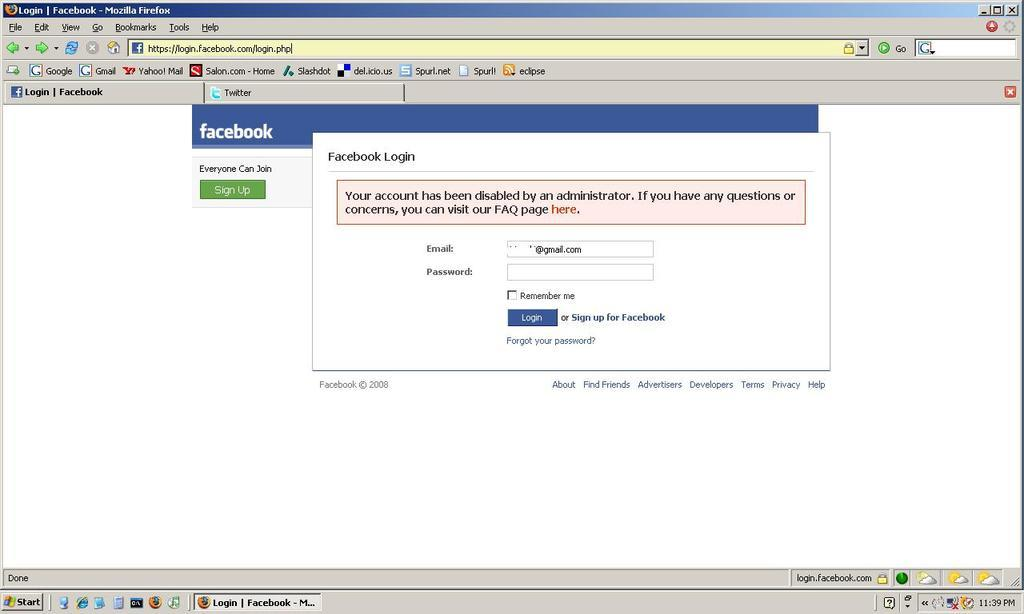<image>
Give a short and clear explanation of the subsequent image. A facebook login issue being shown on a laptop screen. 